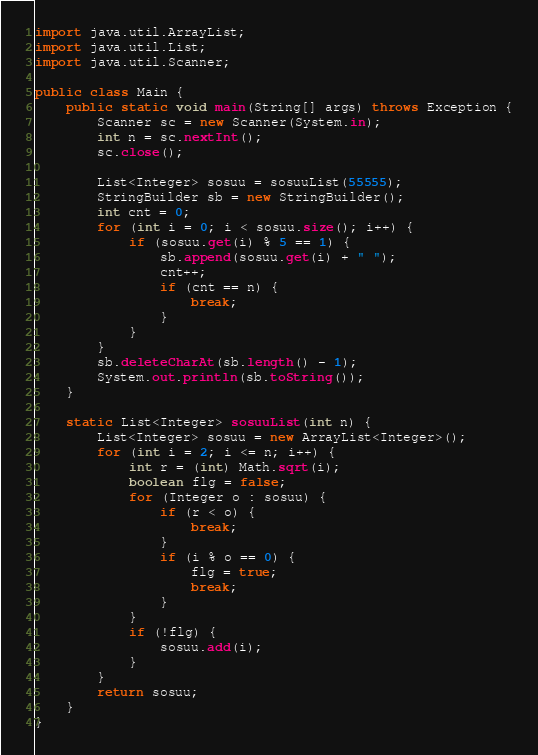<code> <loc_0><loc_0><loc_500><loc_500><_Java_>import java.util.ArrayList;
import java.util.List;
import java.util.Scanner;

public class Main {
	public static void main(String[] args) throws Exception {
		Scanner sc = new Scanner(System.in);
		int n = sc.nextInt();
		sc.close();

		List<Integer> sosuu = sosuuList(55555);
		StringBuilder sb = new StringBuilder();
		int cnt = 0;
		for (int i = 0; i < sosuu.size(); i++) {
			if (sosuu.get(i) % 5 == 1) {
				sb.append(sosuu.get(i) + " ");
				cnt++;
				if (cnt == n) {
					break;
				}
			}
		}
		sb.deleteCharAt(sb.length() - 1);
		System.out.println(sb.toString());
	}

	static List<Integer> sosuuList(int n) {
		List<Integer> sosuu = new ArrayList<Integer>();
		for (int i = 2; i <= n; i++) {
			int r = (int) Math.sqrt(i);
			boolean flg = false;
			for (Integer o : sosuu) {
				if (r < o) {
					break;
				}
				if (i % o == 0) {
					flg = true;
					break;
				}
			}
			if (!flg) {
				sosuu.add(i);
			}
		}
		return sosuu;
	}
}
</code> 